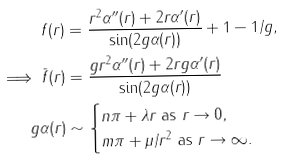Convert formula to latex. <formula><loc_0><loc_0><loc_500><loc_500>f ( r ) & = \frac { r ^ { 2 } \alpha ^ { \prime \prime } ( r ) + 2 r \alpha ^ { \prime } ( r ) } { \sin ( 2 g \alpha ( r ) ) } + 1 - 1 / g , \\ \implies \bar { f } ( r ) & = \frac { g r ^ { 2 } \alpha ^ { \prime \prime } ( r ) + 2 r g \alpha ^ { \prime } ( r ) } { \sin ( 2 g \alpha ( r ) ) } \\ g \alpha ( r ) & \sim \begin{cases} n \pi + \lambda r \text { as } r \to 0 , \\ m \pi + \mu / r ^ { 2 } \text { as } r \to \infty . \end{cases}</formula> 